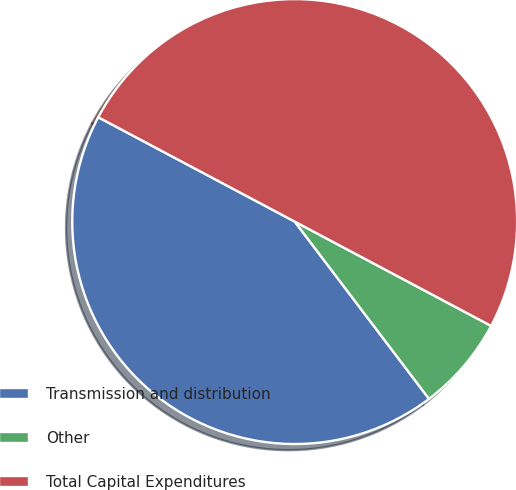<chart> <loc_0><loc_0><loc_500><loc_500><pie_chart><fcel>Transmission and distribution<fcel>Other<fcel>Total Capital Expenditures<nl><fcel>43.09%<fcel>6.91%<fcel>50.0%<nl></chart> 